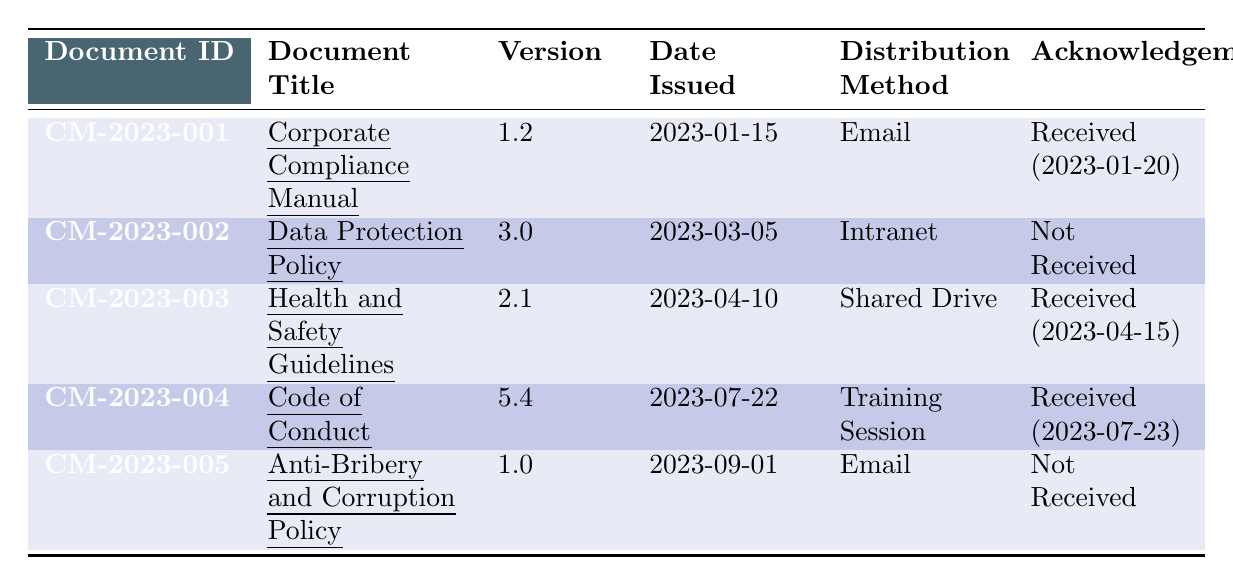What is the Document ID for the "Corporate Compliance Manual"? The Document ID is clearly provided in the first column of the row corresponding to the "Corporate Compliance Manual" title. It is listed as CM-2023-001.
Answer: CM-2023-001 Which document was issued on March 5, 2023? By scanning the Date Issued column, the document with the date 2023-03-05 is the "Data Protection Policy".
Answer: Data Protection Policy How many documents have received acknowledgements? I need to count the rows where "Acknowledgement" indicates "Received." There are three documents with acknowledgements received: "Corporate Compliance Manual," "Health and Safety Guidelines," and "Code of Conduct."
Answer: 3 What is the distribution method for the "Anti-Bribery and Corruption Policy"? The distribution method is specified in the corresponding row under the Distribution Method column for "Anti-Bribery and Corruption Policy," which shows "Email."
Answer: Email Is the acknowledgement for the "Health and Safety Guidelines" received? Looking at the "Acknowledgement" column for "Health and Safety Guidelines," it states "Received (2023-04-15)," indicating that the acknowledgement was received.
Answer: Yes Which document has the highest version number and what is that version? I need to compare version numbers listed in the Version column. The highest version found is 5.4 for the "Code of Conduct."
Answer: Code of Conduct, Version 5.4 Which recipients did not acknowledge the "Data Protection Policy"? The "Data Protection Policy" was distributed to three recipients: Michael Brown, Sarah Wilson, and David Garcia, and since acknowledgement is not received, all three did not acknowledge it.
Answer: Michael Brown, Sarah Wilson, David Garcia What is the difference in the version numbers between the "Corporate Compliance Manual" and the "Anti-Bribery and Corruption Policy"? I need to subtract the version of "Anti-Bribery and Corruption Policy" (1.0) from "Corporate Compliance Manual" (1.2). Therefore, 1.2 - 1.0 = 0.2.
Answer: 0.2 From which method were the least number of documents distributed? I need to evaluate the Distribution Method column to see how many times each method appears. "Training Session" was only used once.
Answer: Training Session If no acknowledgements were received, which documents were impacted? The documents listed as "Not Received" in the Acknowledgement column are "Data Protection Policy" and "Anti-Bribery and Corruption Policy."
Answer: Data Protection Policy, Anti-Bribery and Corruption Policy 